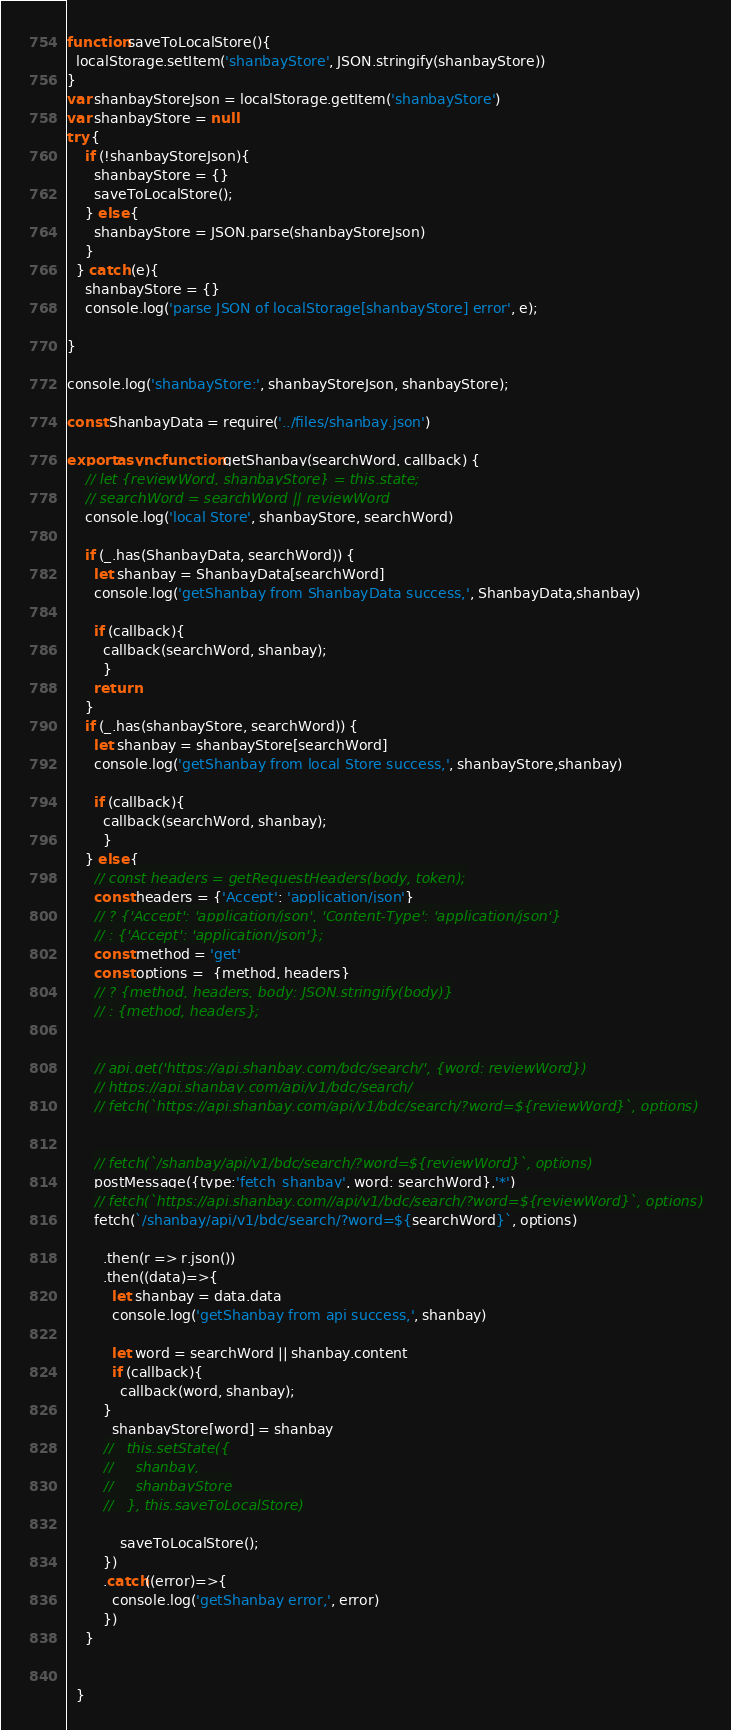<code> <loc_0><loc_0><loc_500><loc_500><_JavaScript_>function saveToLocalStore(){
  localStorage.setItem('shanbayStore', JSON.stringify(shanbayStore))
}
var shanbayStoreJson = localStorage.getItem('shanbayStore')
var shanbayStore = null
try {
    if (!shanbayStoreJson){
      shanbayStore = {}      
      saveToLocalStore();
    } else {
      shanbayStore = JSON.parse(shanbayStoreJson)      
    }
  } catch (e){
    shanbayStore = {}
    console.log('parse JSON of localStorage[shanbayStore] error', e);

}

console.log('shanbayStore:', shanbayStoreJson, shanbayStore);

const ShanbayData = require('../files/shanbay.json')

export async function getShanbay(searchWord, callback) {
    // let {reviewWord, shanbayStore} = this.state;
    // searchWord = searchWord || reviewWord
    console.log('local Store', shanbayStore, searchWord)

    if (_.has(ShanbayData, searchWord)) {
      let shanbay = ShanbayData[searchWord]
      console.log('getShanbay from ShanbayData success,', ShanbayData,shanbay)

      if (callback){
        callback(searchWord, shanbay);
        }
      return
    }
    if (_.has(shanbayStore, searchWord)) {
      let shanbay = shanbayStore[searchWord]
      console.log('getShanbay from local Store success,', shanbayStore,shanbay)

      if (callback){
        callback(searchWord, shanbay);
        }
    } else {
      // const headers = getRequestHeaders(body, token);
      const headers = {'Accept': 'application/json'}
      // ? {'Accept': 'application/json', 'Content-Type': 'application/json'}
      // : {'Accept': 'application/json'};
      const method = 'get'
      const options =  {method, headers}
      // ? {method, headers, body: JSON.stringify(body)}
      // : {method, headers};


      // api.get('https://api.shanbay.com/bdc/search/', {word: reviewWord})
      // https://api.shanbay.com/api/v1/bdc/search/
      // fetch(`https://api.shanbay.com/api/v1/bdc/search/?word=${reviewWord}`, options)


      // fetch(`/shanbay/api/v1/bdc/search/?word=${reviewWord}`, options)
      postMessage({type:'fetch_shanbay', word: searchWord},'*')
      // fetch(`https://api.shanbay.com//api/v1/bdc/search/?word=${reviewWord}`, options)
      fetch(`/shanbay/api/v1/bdc/search/?word=${searchWord}`, options)

        .then(r => r.json())
        .then((data)=>{
          let shanbay = data.data
          console.log('getShanbay from api success,', shanbay)

          let word = searchWord || shanbay.content
          if (callback){
            callback(word, shanbay);
        }
          shanbayStore[word] = shanbay
        //   this.setState({
        //     shanbay,
        //     shanbayStore
        //   }, this.saveToLocalStore)
        
            saveToLocalStore();
        })
        .catch((error)=>{
          console.log('getShanbay error,', error)
        })
    }


  }</code> 